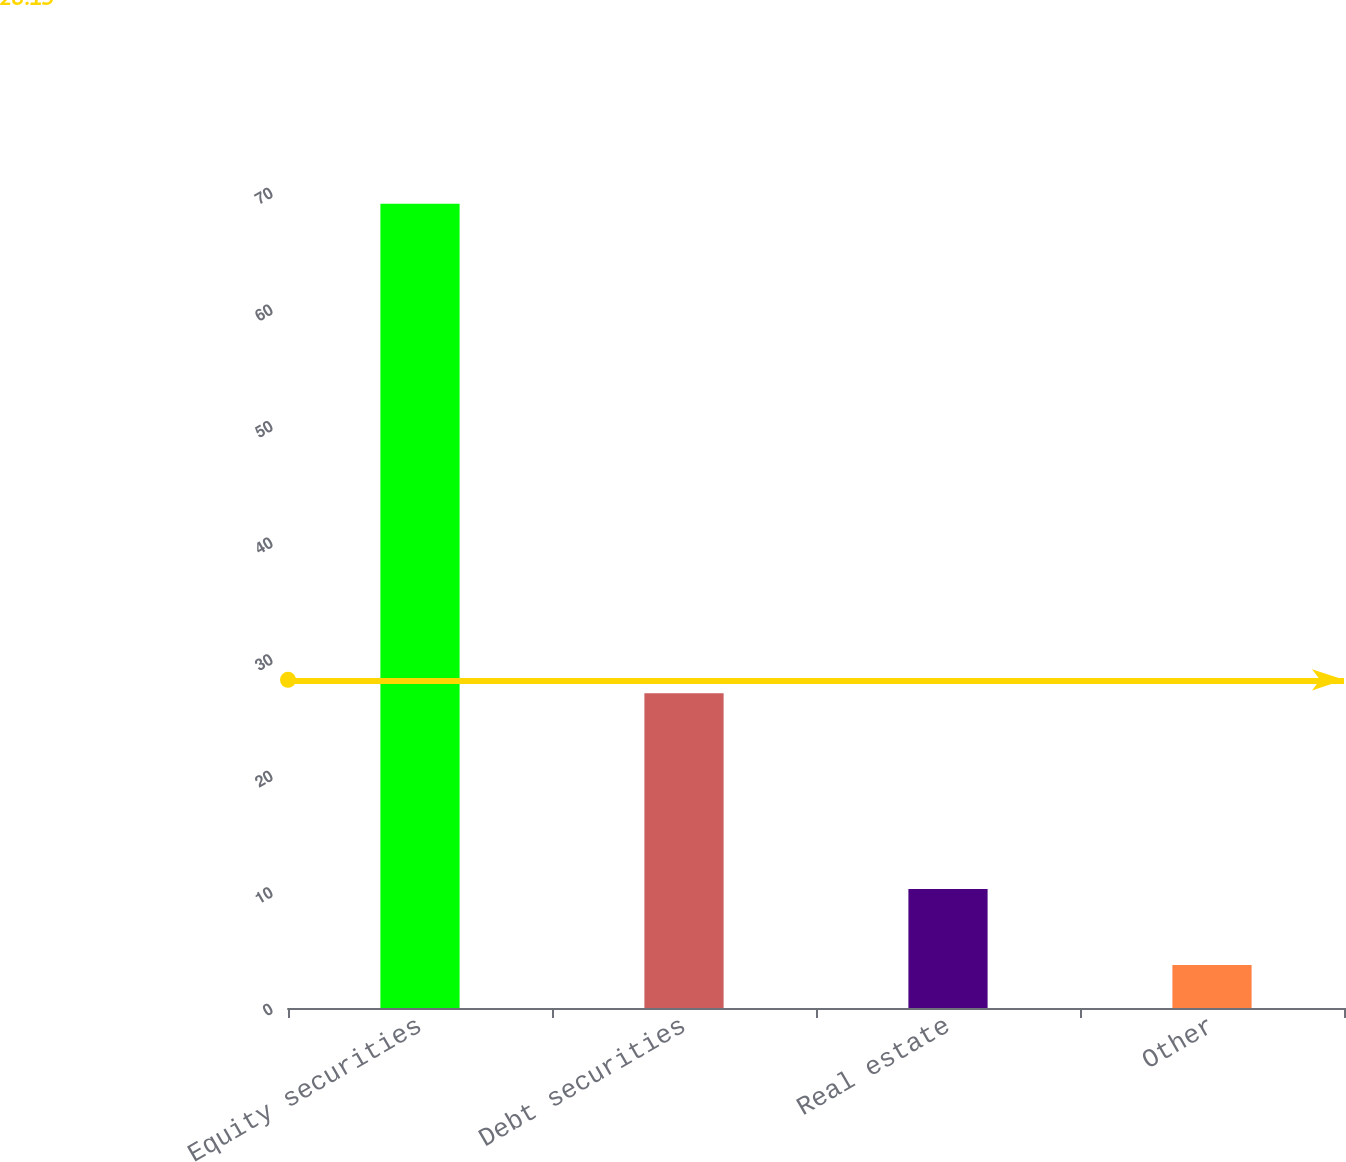<chart> <loc_0><loc_0><loc_500><loc_500><bar_chart><fcel>Equity securities<fcel>Debt securities<fcel>Real estate<fcel>Other<nl><fcel>69<fcel>27<fcel>10.21<fcel>3.68<nl></chart> 